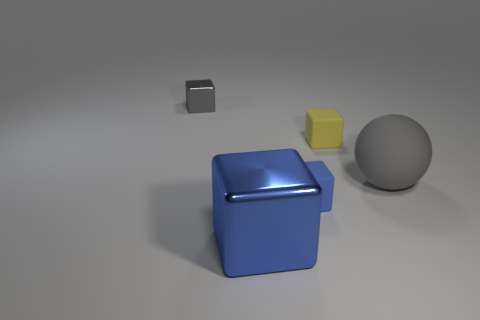Is the number of yellow objects to the right of the gray matte sphere less than the number of blue matte cubes behind the small yellow matte object?
Offer a terse response. No. There is a rubber thing to the right of the yellow matte object; what size is it?
Provide a short and direct response. Large. Is the size of the matte ball the same as the yellow cube?
Offer a very short reply. No. How many rubber objects are both behind the big sphere and in front of the big gray matte ball?
Ensure brevity in your answer.  0. How many gray objects are large balls or rubber blocks?
Offer a terse response. 1. What number of shiny objects are big cyan cylinders or spheres?
Your answer should be compact. 0. Are any large green shiny balls visible?
Make the answer very short. No. Does the tiny gray object have the same shape as the tiny yellow matte thing?
Your answer should be very brief. Yes. How many gray balls are behind the metal object in front of the small thing that is in front of the large gray object?
Your response must be concise. 1. There is a object that is both behind the big blue shiny cube and in front of the big rubber ball; what is it made of?
Ensure brevity in your answer.  Rubber. 